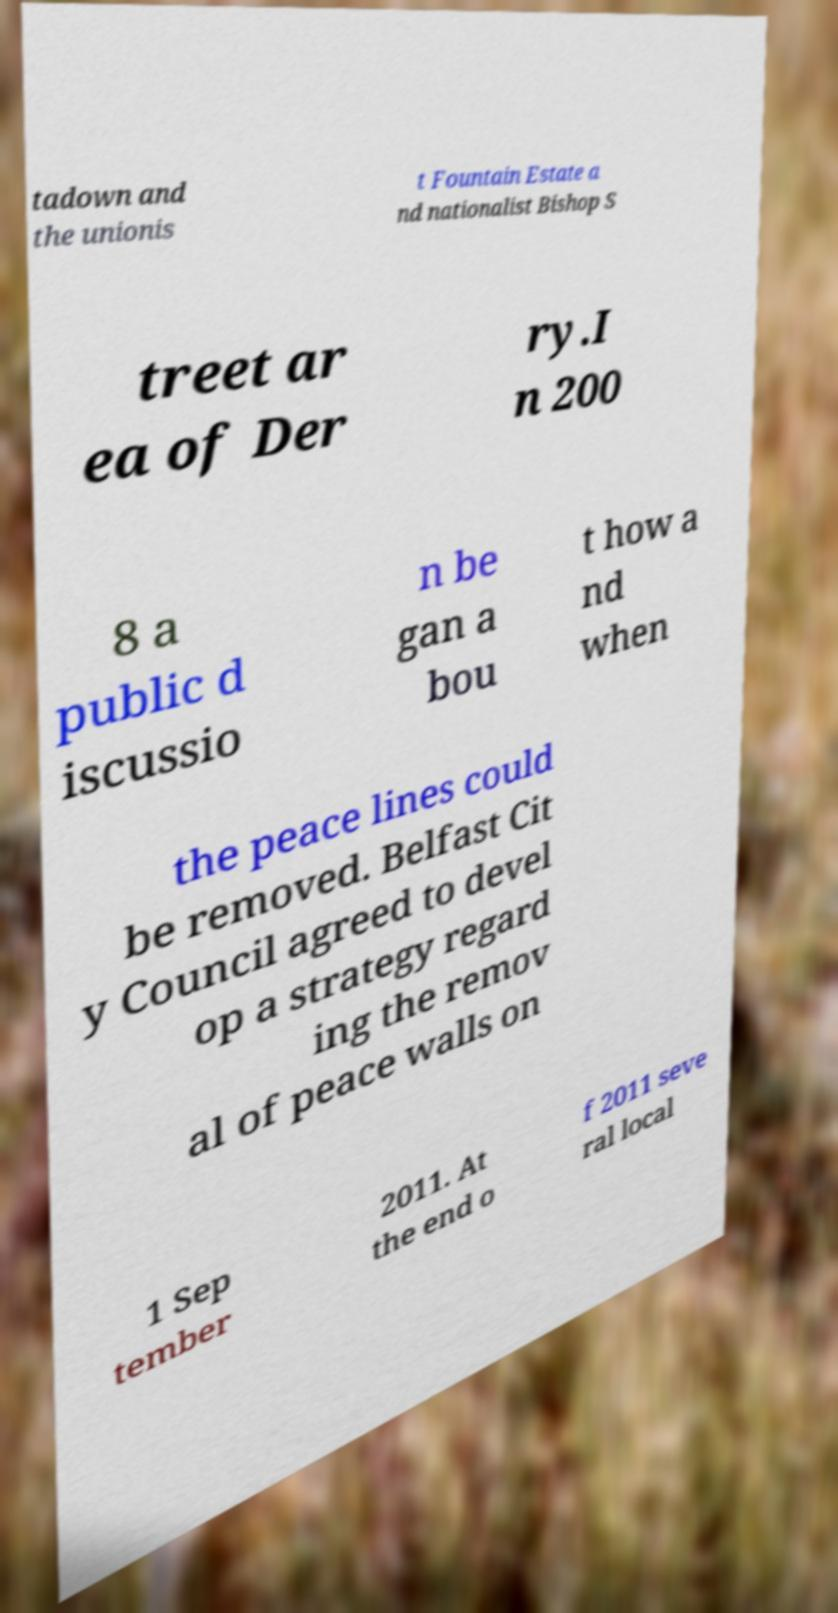What messages or text are displayed in this image? I need them in a readable, typed format. tadown and the unionis t Fountain Estate a nd nationalist Bishop S treet ar ea of Der ry.I n 200 8 a public d iscussio n be gan a bou t how a nd when the peace lines could be removed. Belfast Cit y Council agreed to devel op a strategy regard ing the remov al of peace walls on 1 Sep tember 2011. At the end o f 2011 seve ral local 